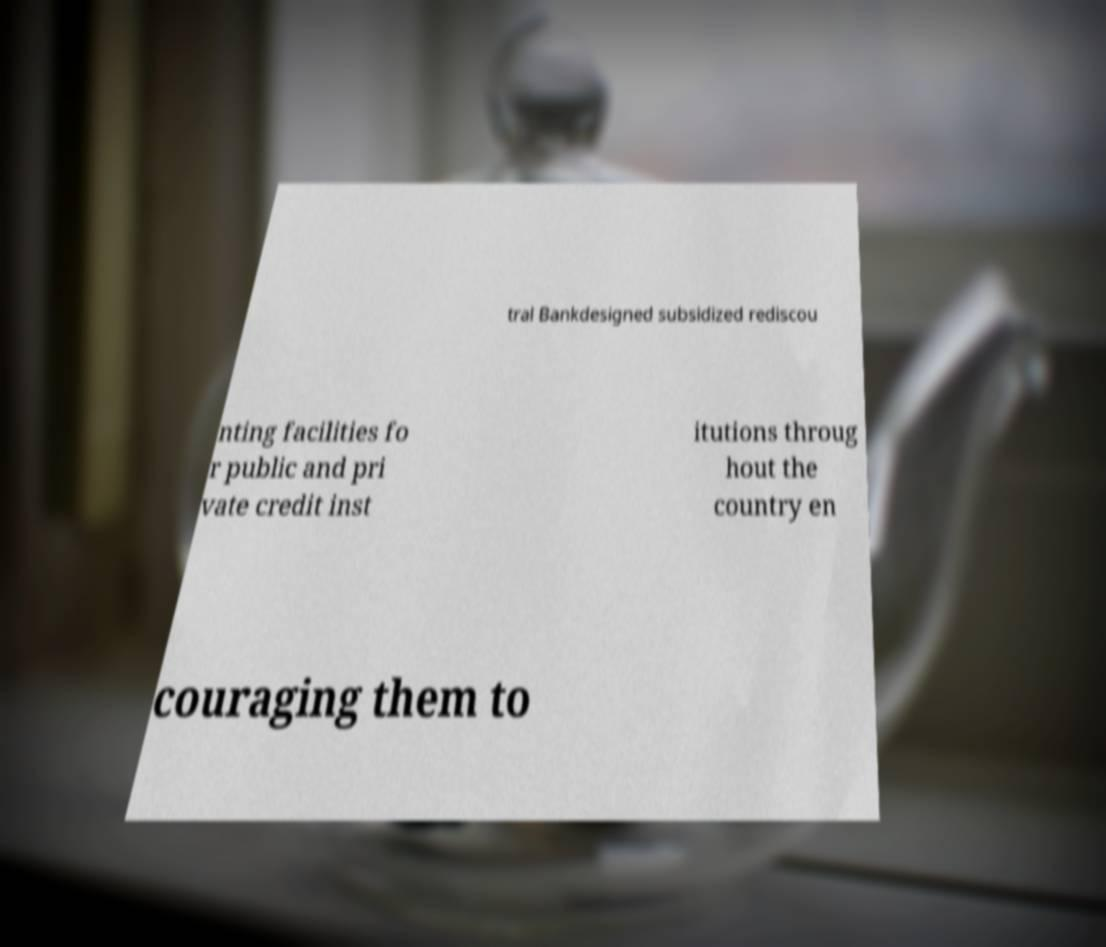Could you extract and type out the text from this image? tral Bankdesigned subsidized rediscou nting facilities fo r public and pri vate credit inst itutions throug hout the country en couraging them to 